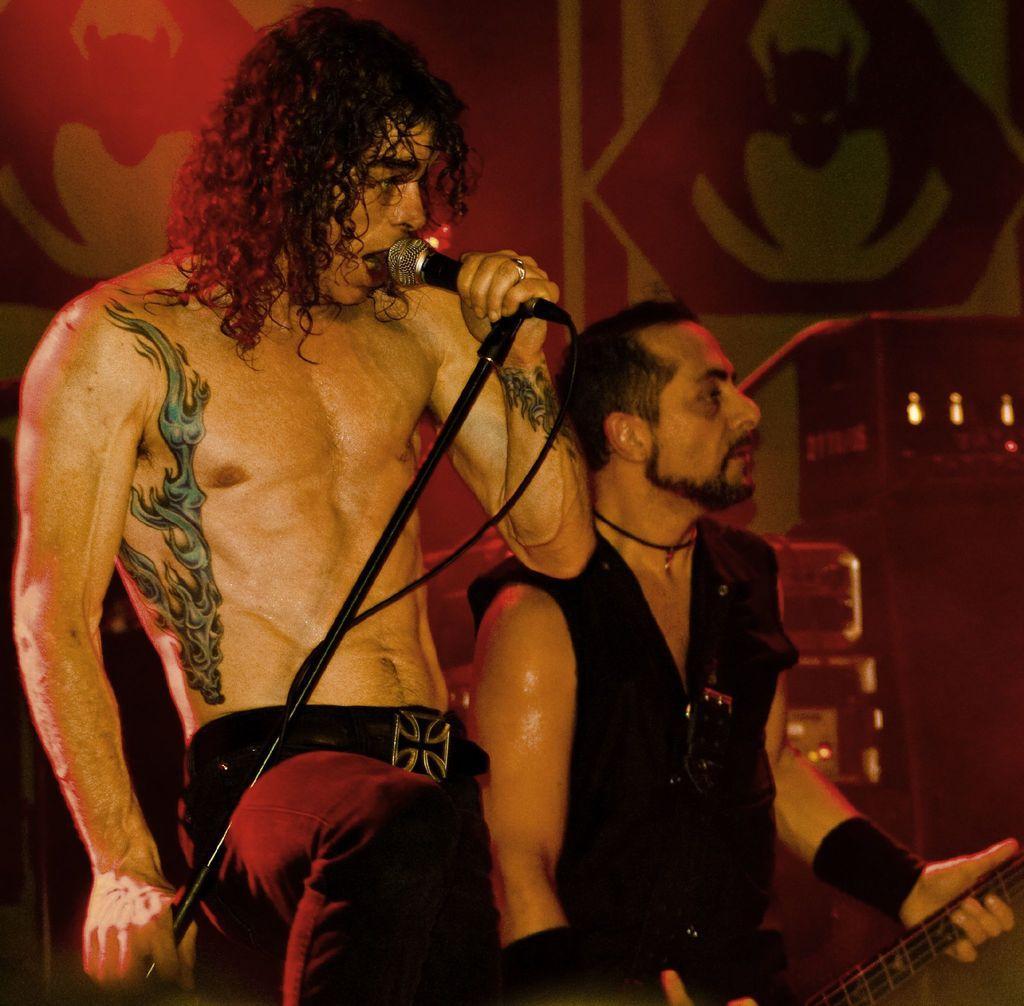Can you describe this image briefly? In this picture we can see a man with short hair holding the mic and beside him there is a guy who is holding the guitar. 